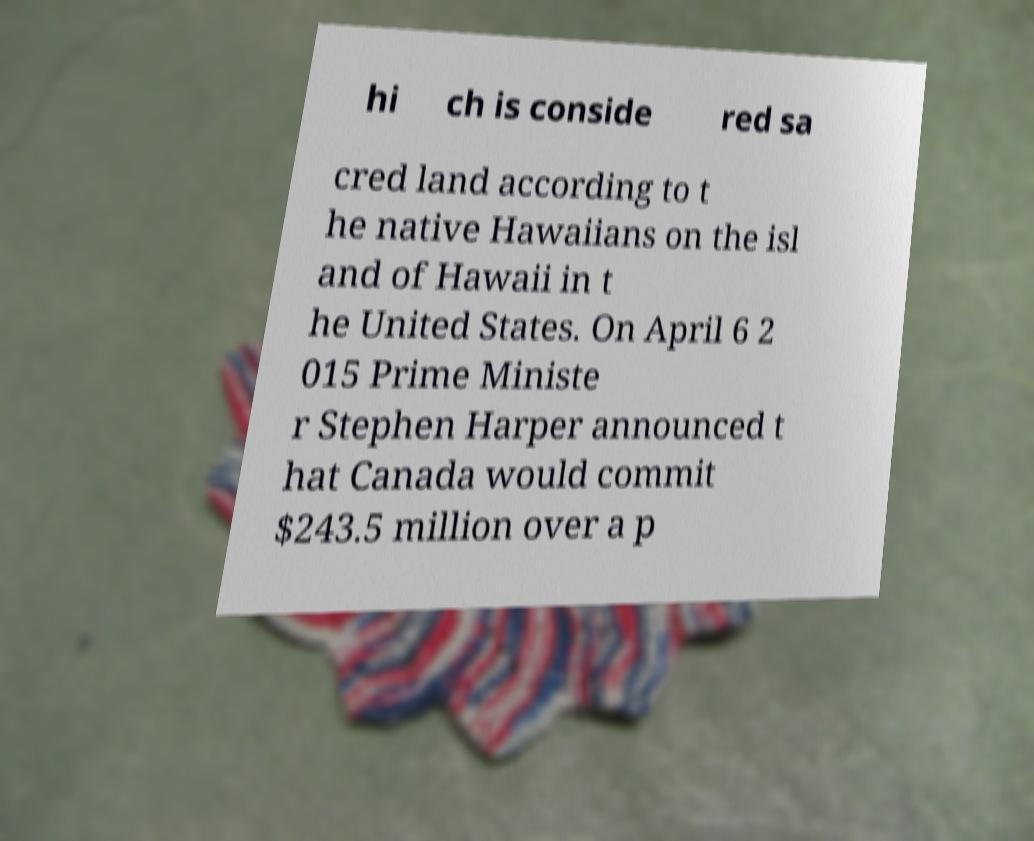Can you accurately transcribe the text from the provided image for me? hi ch is conside red sa cred land according to t he native Hawaiians on the isl and of Hawaii in t he United States. On April 6 2 015 Prime Ministe r Stephen Harper announced t hat Canada would commit $243.5 million over a p 